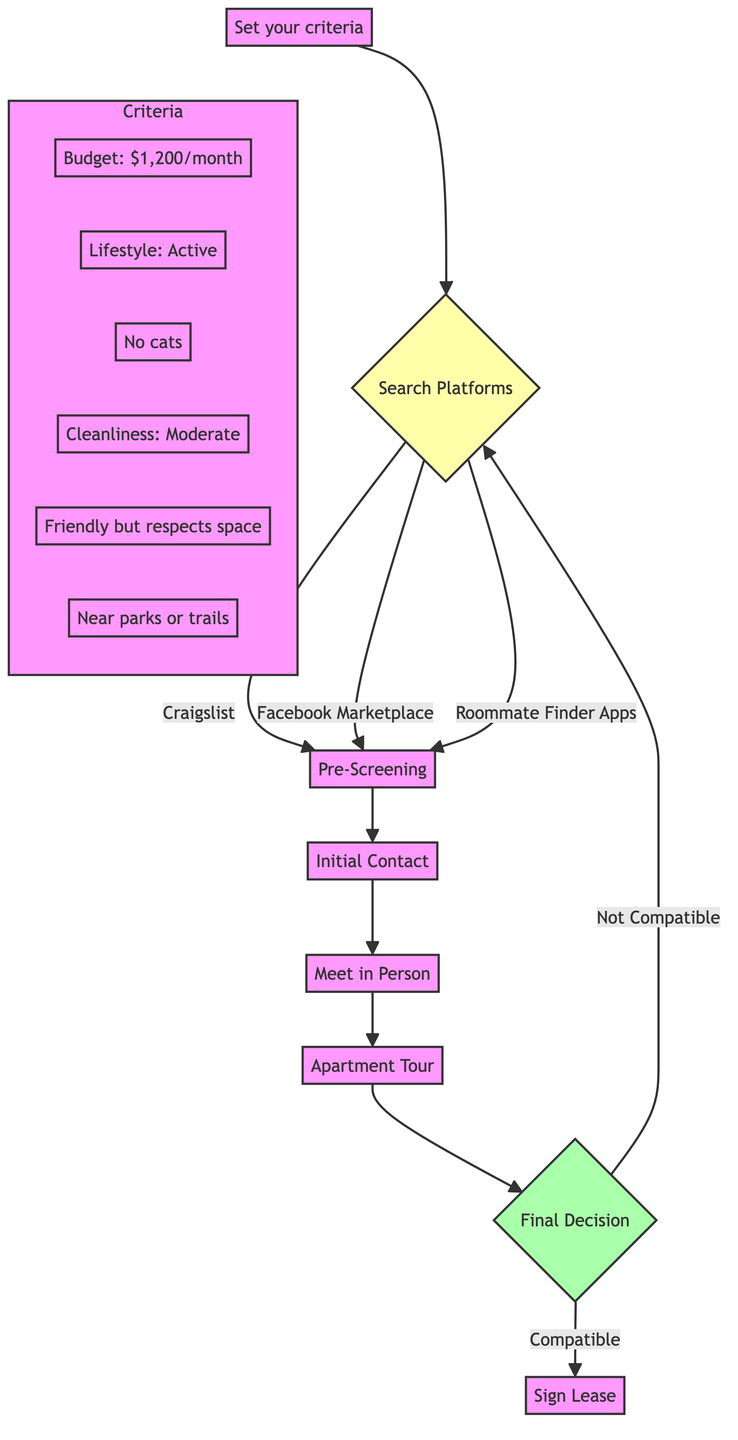What is the first action in the flow chart? The first action in the flow chart is setting your criteria, which is the starting node labeled "Set your criteria."
Answer: Set your criteria How many search platforms are mentioned in the diagram? The diagram lists three search platforms: Craigslist, Facebook Marketplace, and Roommate Finder Apps. Thus, the number is counted as three.
Answer: 3 What is the budget criterion for a suitable roommate? According to the criteria section, the budget criterion specified is a maximum of $1,200 per month.
Answer: Maximum $1,200/month What happens if a potential roommate is not compatible? If a potential roommate is found to be not compatible during the final decision stage, the flow chart indicates that the process returns back to the "Search Platforms" step, suggesting repeated searching.
Answer: Return to Search Platforms What type of place is suggested for meeting in person? The diagram recommends meeting in a public place like a coffee shop for the initial in-person discussion.
Answer: Coffee shop What is included in the pre-screening process? The pre-screening process consists of a background check, reference check, and social media review as detailed in that section of the diagram.
Answer: Background check, Reference check, Social media review What is the conclusion of the decision-making process? The final decision node leads to two outcomes: signing the lease if compatible or returning to search platforms if not compatible.
Answer: Sign Lease or Return to Search Platforms What should be discussed during the apartment tour? During the apartment tour, it is suggested to discuss the rent and utilities split, show the room and amenities, and review lease terms and conditions.
Answer: Discuss rent and utilities split, Show room and amenities What is a criterion regarding pets in the search for a roommate? The criteria stipulate a preference for no cats, due to allergies, indicating an important consideration in the roommate search.
Answer: Preferably no cats 